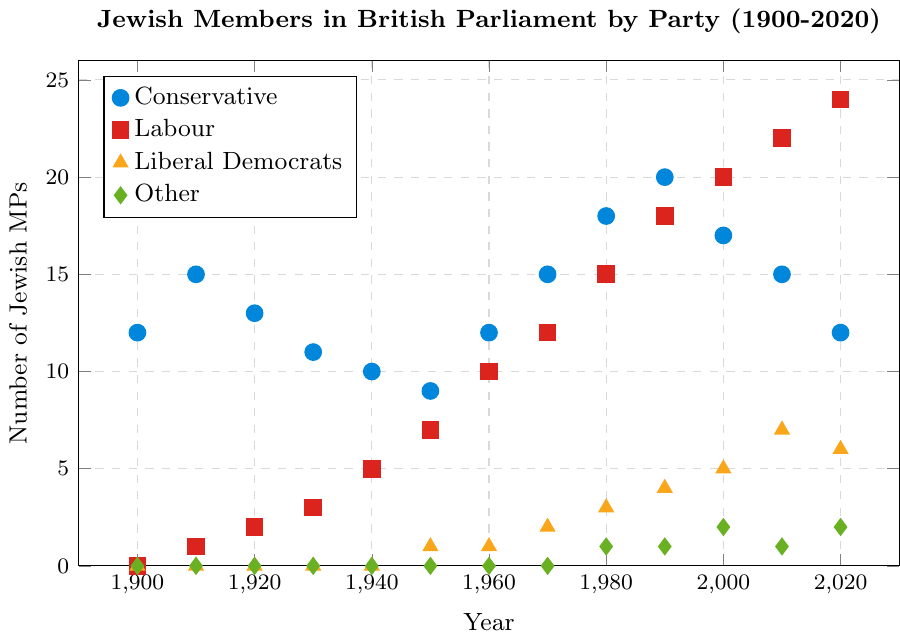What's the trend in the number of Jewish MPs from the Labour party from 1900 to 2020? The number of Jewish MPs from the Labour party shows a general increase over the years, starting with 0 in 1900 and ending with 24 in 2020. By looking at each decade, one can observe a steady rise in the proportion of Jewish MPs in the Labour party.
Answer: Increase In which year did the Conservative party have the highest number of Jewish MPs? Looking at the plot, the Conservative party reached its peak number of Jewish MPs in 1990, with a total of 20.
Answer: 1990 Compare the number of Jewish MPs between the Conservative and Liberal Democrats in 1980. In 1980, the Conservative party had 18 Jewish MPs, while the Liberal Democrats had 3. Therefore, the Conservative party had significantly more Jewish MPs than the Liberal Democrats at that time.
Answer: Conservative Which political party had the most Jewish MPs in 2020? To determine this, examine the dots for 2020 and compare the values for each party. Labour had the highest with 24 Jewish MPs in 2020.
Answer: Labour What is the difference in the number of Jewish MPs between Labour and Conservative in 2010? In 2010, Labour had 22 Jewish MPs while the Conservative party had 15. The difference is calculated by subtracting 15 from 22, resulting in 7.
Answer: 7 How many political parties had Jewish MPs represented in 1950? By examining the dots for the year 1950, one can see that three political parties (Conservative, Labour, and Liberal Democrats) had Jewish MPs, represented by non-zero values.
Answer: 3 What is the average number of Jewish MPs in the "Other" category from 1980 to 2020? The number of Jewish MPs in the "Other" category for the years 1980, 1990, 2000, 2010, and 2020 are 1, 1, 2, 1, and 2 respectively. The average is calculated by summing these values (1+1+2+1+2 = 7) and dividing by the number of years (5). Thus, the average is 7/5 = 1.4.
Answer: 1.4 Which party showed the most dramatic increase in the number of Jewish MPs between the decades of 1950 and 1960? Comparing the plots for 1950 and 1960, Labour showed the most dramatic increase, going from 7 MPs in 1950 to 10 MPs in 1960, an increase of 3 MPs.
Answer: Labour How many times did the number of Jewish MPs for the Conservative party stay constant between consecutive decades? The number of Jewish MPs for the Conservative party stayed constant between the years 1900-1910, 1960-1970, and 2010-2020. Thus, it remained constant three times.
Answer: 3 